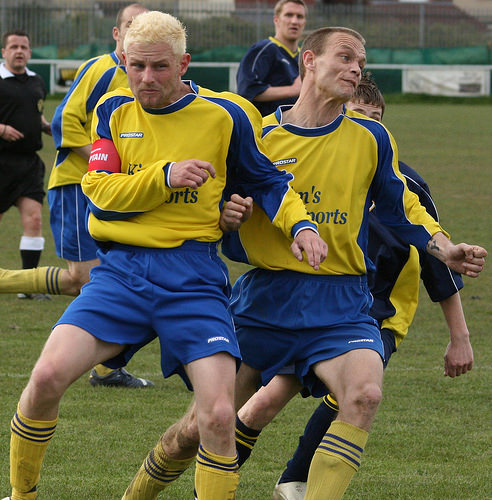<image>
Can you confirm if the jersey is on the man? No. The jersey is not positioned on the man. They may be near each other, but the jersey is not supported by or resting on top of the man. 